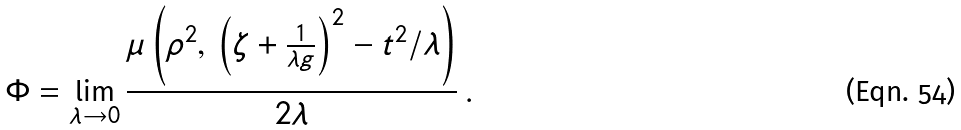<formula> <loc_0><loc_0><loc_500><loc_500>\Phi = \lim _ { \lambda \rightarrow 0 } \frac { \mu \left ( \rho ^ { 2 } , \, \left ( \zeta + \frac { 1 } { \lambda g } \right ) ^ { 2 } - t ^ { 2 } / \lambda \right ) } { 2 \lambda } \, .</formula> 